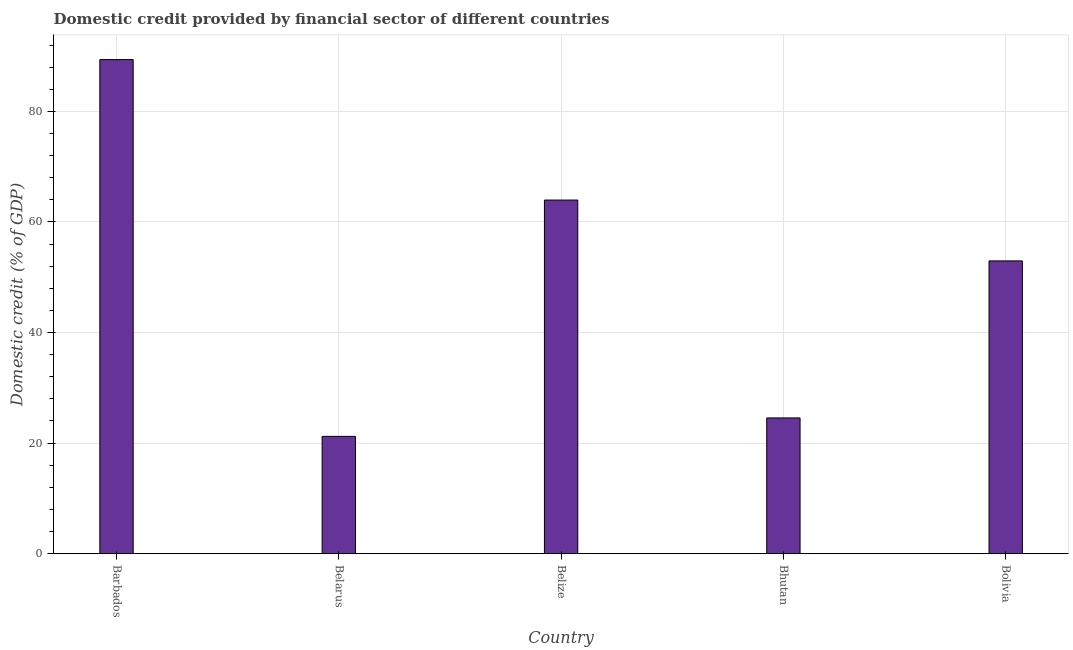What is the title of the graph?
Offer a very short reply. Domestic credit provided by financial sector of different countries. What is the label or title of the X-axis?
Provide a succinct answer. Country. What is the label or title of the Y-axis?
Provide a succinct answer. Domestic credit (% of GDP). What is the domestic credit provided by financial sector in Bolivia?
Provide a succinct answer. 52.95. Across all countries, what is the maximum domestic credit provided by financial sector?
Keep it short and to the point. 89.37. Across all countries, what is the minimum domestic credit provided by financial sector?
Give a very brief answer. 21.21. In which country was the domestic credit provided by financial sector maximum?
Keep it short and to the point. Barbados. In which country was the domestic credit provided by financial sector minimum?
Ensure brevity in your answer.  Belarus. What is the sum of the domestic credit provided by financial sector?
Your answer should be compact. 252.04. What is the difference between the domestic credit provided by financial sector in Belize and Bhutan?
Offer a terse response. 39.41. What is the average domestic credit provided by financial sector per country?
Make the answer very short. 50.41. What is the median domestic credit provided by financial sector?
Offer a very short reply. 52.95. In how many countries, is the domestic credit provided by financial sector greater than 72 %?
Your response must be concise. 1. What is the ratio of the domestic credit provided by financial sector in Belarus to that in Bhutan?
Give a very brief answer. 0.86. Is the difference between the domestic credit provided by financial sector in Barbados and Belarus greater than the difference between any two countries?
Keep it short and to the point. Yes. What is the difference between the highest and the second highest domestic credit provided by financial sector?
Ensure brevity in your answer.  25.41. What is the difference between the highest and the lowest domestic credit provided by financial sector?
Provide a short and direct response. 68.16. Are all the bars in the graph horizontal?
Offer a terse response. No. How many countries are there in the graph?
Make the answer very short. 5. What is the Domestic credit (% of GDP) of Barbados?
Provide a succinct answer. 89.37. What is the Domestic credit (% of GDP) in Belarus?
Offer a terse response. 21.21. What is the Domestic credit (% of GDP) in Belize?
Keep it short and to the point. 63.96. What is the Domestic credit (% of GDP) of Bhutan?
Offer a very short reply. 24.55. What is the Domestic credit (% of GDP) in Bolivia?
Offer a terse response. 52.95. What is the difference between the Domestic credit (% of GDP) in Barbados and Belarus?
Provide a short and direct response. 68.16. What is the difference between the Domestic credit (% of GDP) in Barbados and Belize?
Ensure brevity in your answer.  25.41. What is the difference between the Domestic credit (% of GDP) in Barbados and Bhutan?
Ensure brevity in your answer.  64.82. What is the difference between the Domestic credit (% of GDP) in Barbados and Bolivia?
Your answer should be compact. 36.42. What is the difference between the Domestic credit (% of GDP) in Belarus and Belize?
Provide a succinct answer. -42.75. What is the difference between the Domestic credit (% of GDP) in Belarus and Bhutan?
Your response must be concise. -3.34. What is the difference between the Domestic credit (% of GDP) in Belarus and Bolivia?
Your answer should be very brief. -31.74. What is the difference between the Domestic credit (% of GDP) in Belize and Bhutan?
Your answer should be very brief. 39.41. What is the difference between the Domestic credit (% of GDP) in Belize and Bolivia?
Your response must be concise. 11.01. What is the difference between the Domestic credit (% of GDP) in Bhutan and Bolivia?
Give a very brief answer. -28.4. What is the ratio of the Domestic credit (% of GDP) in Barbados to that in Belarus?
Keep it short and to the point. 4.21. What is the ratio of the Domestic credit (% of GDP) in Barbados to that in Belize?
Offer a terse response. 1.4. What is the ratio of the Domestic credit (% of GDP) in Barbados to that in Bhutan?
Provide a short and direct response. 3.64. What is the ratio of the Domestic credit (% of GDP) in Barbados to that in Bolivia?
Offer a terse response. 1.69. What is the ratio of the Domestic credit (% of GDP) in Belarus to that in Belize?
Ensure brevity in your answer.  0.33. What is the ratio of the Domestic credit (% of GDP) in Belarus to that in Bhutan?
Ensure brevity in your answer.  0.86. What is the ratio of the Domestic credit (% of GDP) in Belarus to that in Bolivia?
Ensure brevity in your answer.  0.4. What is the ratio of the Domestic credit (% of GDP) in Belize to that in Bhutan?
Your answer should be very brief. 2.6. What is the ratio of the Domestic credit (% of GDP) in Belize to that in Bolivia?
Offer a terse response. 1.21. What is the ratio of the Domestic credit (% of GDP) in Bhutan to that in Bolivia?
Your answer should be compact. 0.46. 